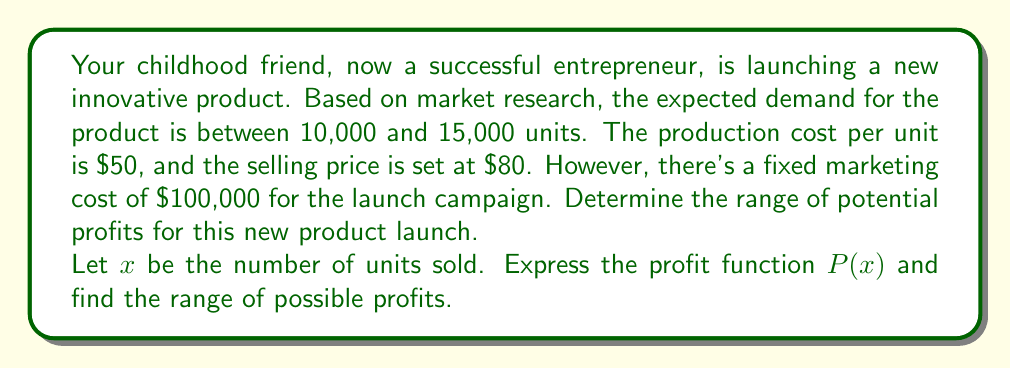Can you answer this question? Let's approach this step-by-step:

1) First, let's define the profit function $P(x)$:
   
   Profit = Revenue - Total Costs
   $$P(x) = \text{Revenue} - (\text{Production Costs} + \text{Fixed Marketing Cost})$$
   $$P(x) = 80x - (50x + 100,000)$$
   $$P(x) = 80x - 50x - 100,000$$
   $$P(x) = 30x - 100,000$$

2) Now, we know that $x$ is between 10,000 and 15,000 units:
   $$10,000 \leq x \leq 15,000$$

3) To find the range of profits, we need to calculate the minimum and maximum profits:

   Minimum profit (when $x = 10,000$):
   $$P(10,000) = 30(10,000) - 100,000 = 200,000$$

   Maximum profit (when $x = 15,000$):
   $$P(15,000) = 30(15,000) - 100,000 = 350,000$$

4) Therefore, the range of potential profits is:
   $$200,000 \leq P(x) \leq 350,000$$

This means the profit could be anywhere between $200,000 and $350,000, depending on the actual number of units sold.
Answer: The range of potential profits is $200,000 \leq P(x) \leq 350,000$, where $P(x)$ represents the profit in dollars. 